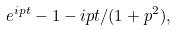Convert formula to latex. <formula><loc_0><loc_0><loc_500><loc_500>e ^ { i p t } - 1 - i p t / ( 1 + p ^ { 2 } ) ,</formula> 